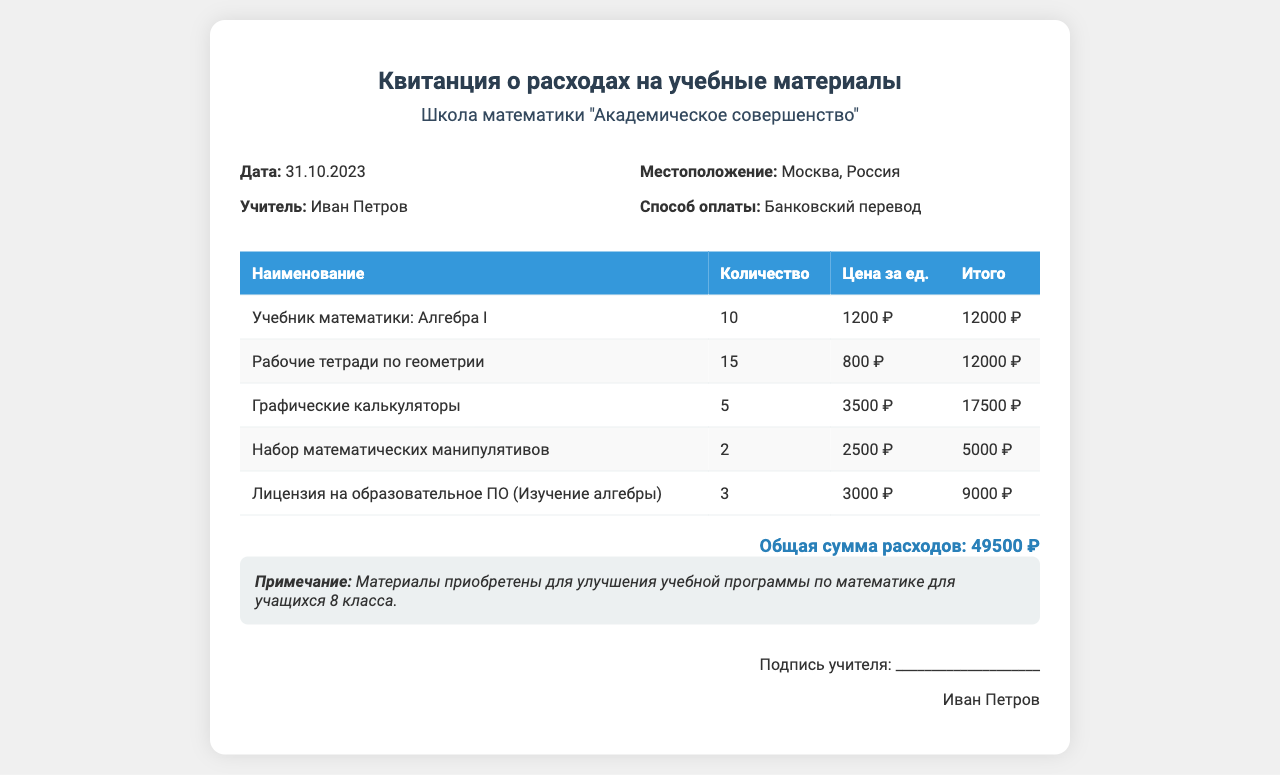what is the date of the receipt? The date is explicitly mentioned in the details section of the document, stating the day the receipt was issued.
Answer: 31.10.2023 who is the teacher named on the receipt? The teacher’s name is indicated in the details section of the document, which shows who made the purchases.
Answer: Иван Петров what is the location of the school? The location can be found in the details section, specifying where the school is based.
Answer: Москва, Россия what is the total amount spent on educational materials? The total amount is summarized at the bottom of the document, indicating the overall expenses for the purchased items.
Answer: 49500 ₽ how many graphic calculators were purchased? The quantity of graphic calculators is listed in the table under the respective item rows, showing the number acquired.
Answer: 5 what educational materials were purchased for Algebra? The document lists different materials bought, specifically mentioning the ones related to algebra for clarity.
Answer: Учебник математики: Алгебра I is there a note on the document? There is a special section for notes in the document that provides additional context or clarifications about the purchases made.
Answer: Материалы приобретены для улучшения учебной программы по математике для учащихся 8 класса what payment method was used? The payment method is detailed in the document, providing insight into how the purchases were settled.
Answer: Банковский перевод how many licenses for educational software were bought? The quantity of licenses is provided in the table detailing educational materials specifically connected to algebra.
Answer: 3 